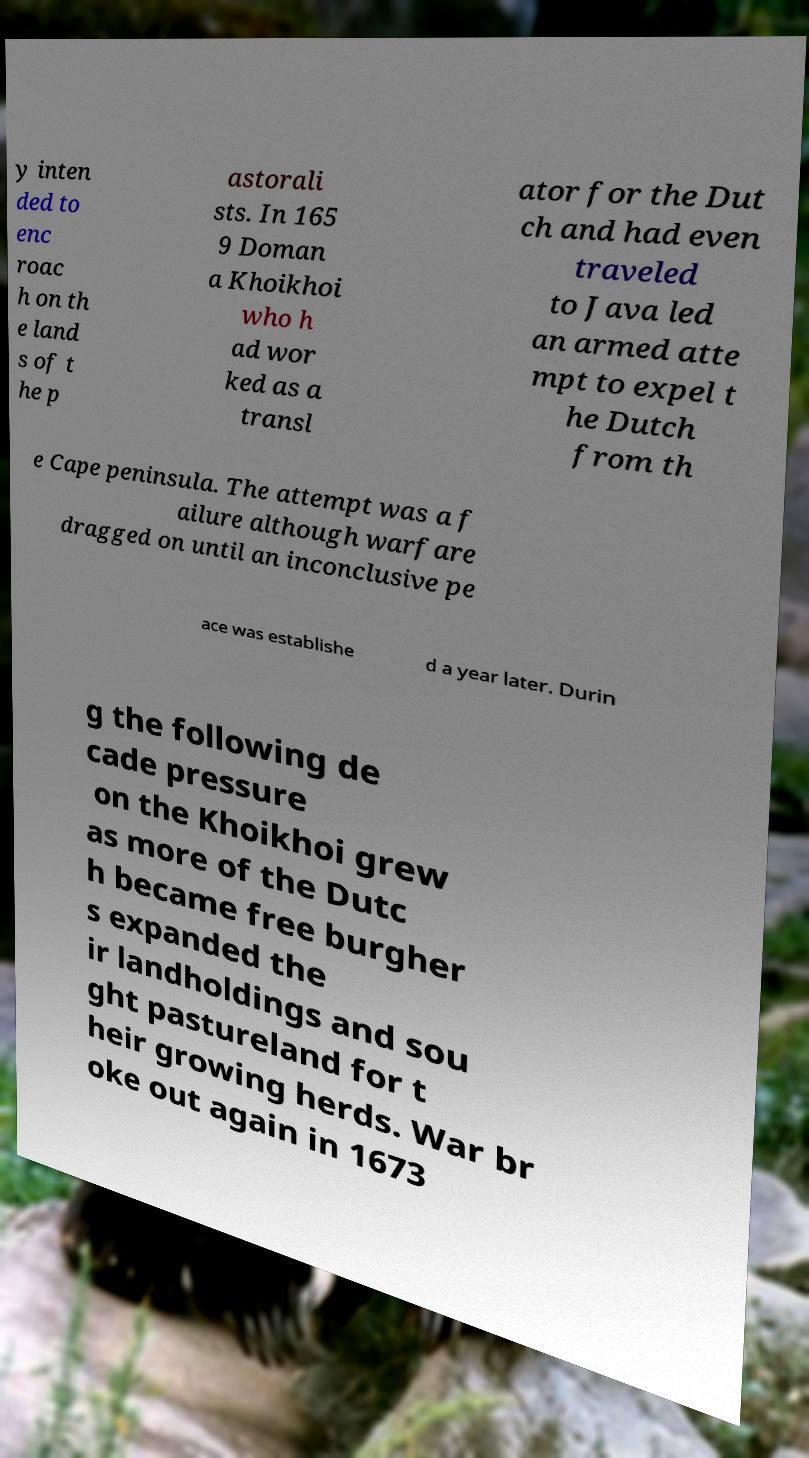For documentation purposes, I need the text within this image transcribed. Could you provide that? y inten ded to enc roac h on th e land s of t he p astorali sts. In 165 9 Doman a Khoikhoi who h ad wor ked as a transl ator for the Dut ch and had even traveled to Java led an armed atte mpt to expel t he Dutch from th e Cape peninsula. The attempt was a f ailure although warfare dragged on until an inconclusive pe ace was establishe d a year later. Durin g the following de cade pressure on the Khoikhoi grew as more of the Dutc h became free burgher s expanded the ir landholdings and sou ght pastureland for t heir growing herds. War br oke out again in 1673 